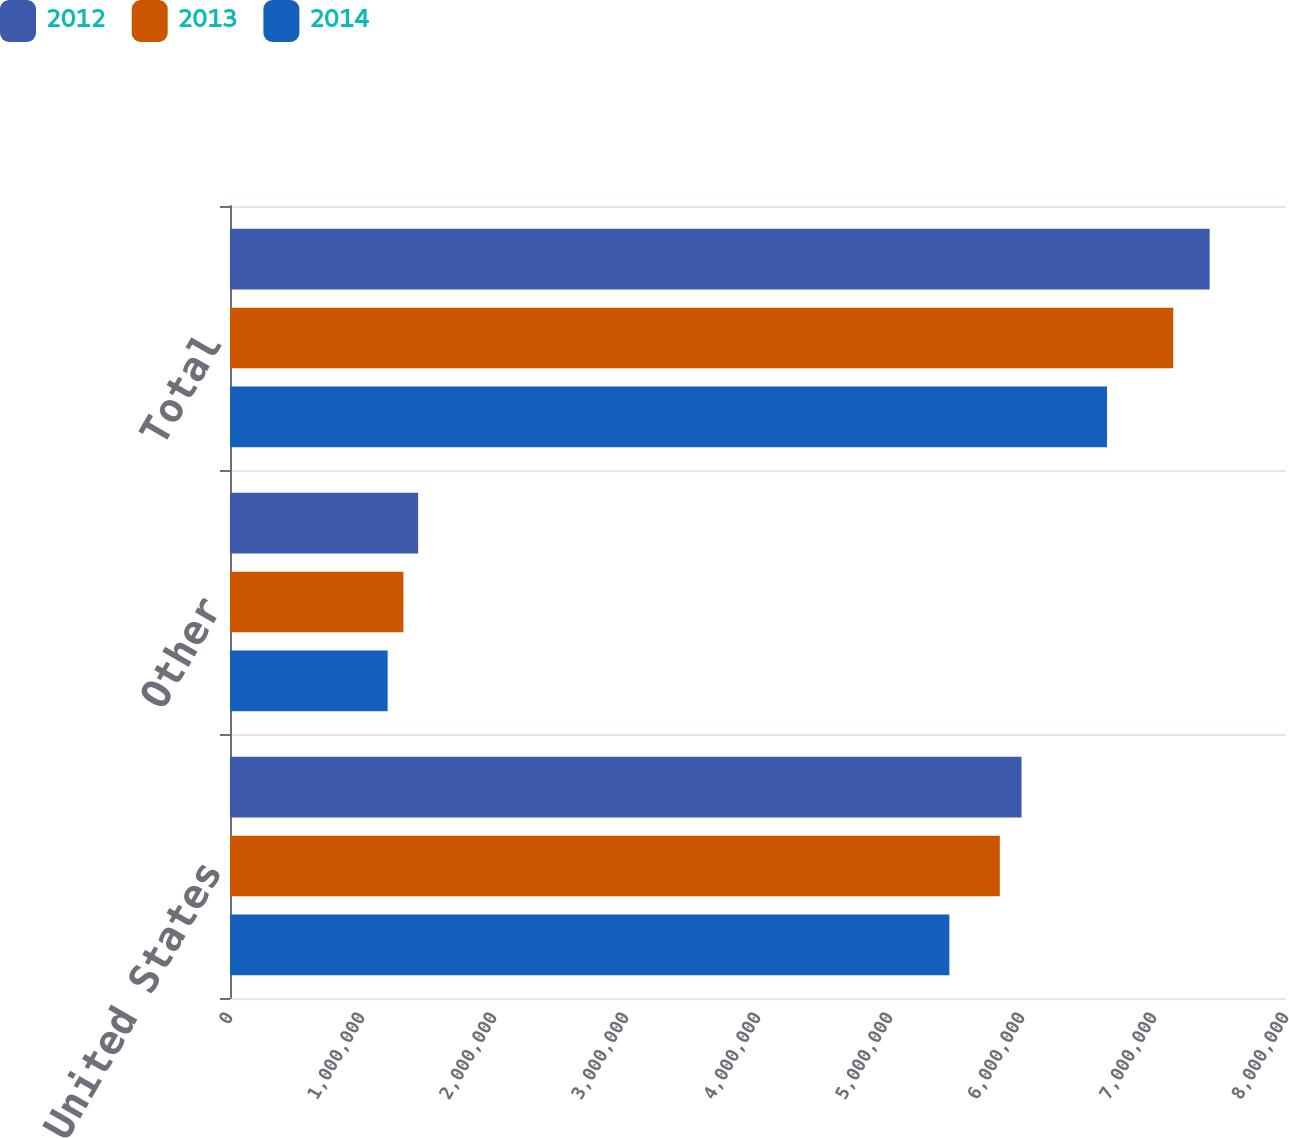Convert chart. <chart><loc_0><loc_0><loc_500><loc_500><stacked_bar_chart><ecel><fcel>United States<fcel>Other<fcel>Total<nl><fcel>2012<fcel>5.99656e+06<fcel>1.4252e+06<fcel>7.42177e+06<nl><fcel>2013<fcel>5.83207e+06<fcel>1.31401e+06<fcel>7.14608e+06<nl><fcel>2014<fcel>5.44988e+06<fcel>1.19438e+06<fcel>6.64425e+06<nl></chart> 